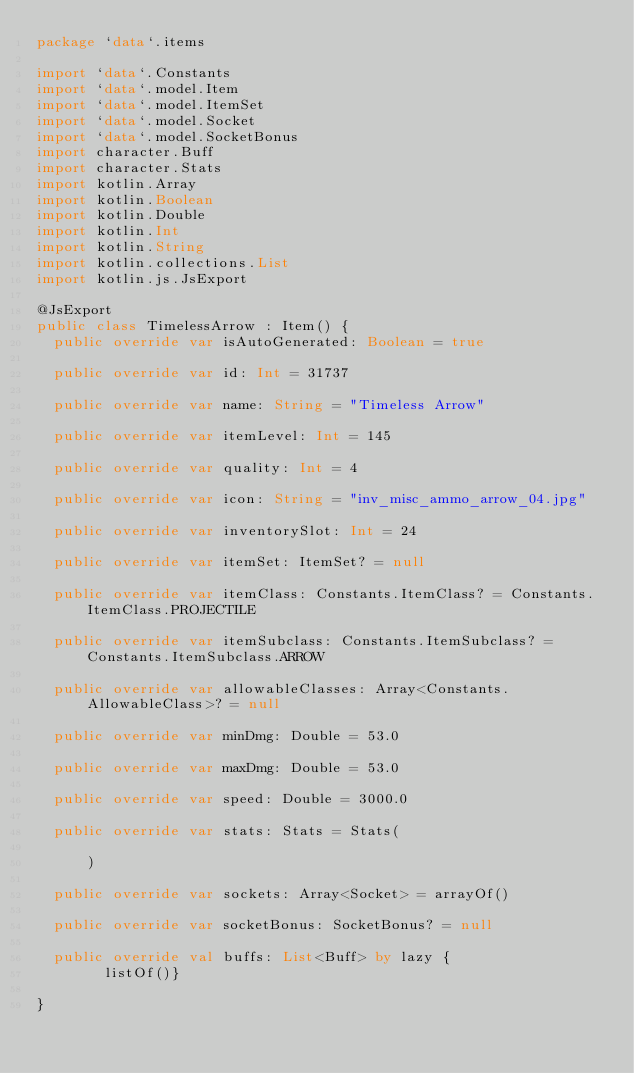Convert code to text. <code><loc_0><loc_0><loc_500><loc_500><_Kotlin_>package `data`.items

import `data`.Constants
import `data`.model.Item
import `data`.model.ItemSet
import `data`.model.Socket
import `data`.model.SocketBonus
import character.Buff
import character.Stats
import kotlin.Array
import kotlin.Boolean
import kotlin.Double
import kotlin.Int
import kotlin.String
import kotlin.collections.List
import kotlin.js.JsExport

@JsExport
public class TimelessArrow : Item() {
  public override var isAutoGenerated: Boolean = true

  public override var id: Int = 31737

  public override var name: String = "Timeless Arrow"

  public override var itemLevel: Int = 145

  public override var quality: Int = 4

  public override var icon: String = "inv_misc_ammo_arrow_04.jpg"

  public override var inventorySlot: Int = 24

  public override var itemSet: ItemSet? = null

  public override var itemClass: Constants.ItemClass? = Constants.ItemClass.PROJECTILE

  public override var itemSubclass: Constants.ItemSubclass? = Constants.ItemSubclass.ARROW

  public override var allowableClasses: Array<Constants.AllowableClass>? = null

  public override var minDmg: Double = 53.0

  public override var maxDmg: Double = 53.0

  public override var speed: Double = 3000.0

  public override var stats: Stats = Stats(

      )

  public override var sockets: Array<Socket> = arrayOf()

  public override var socketBonus: SocketBonus? = null

  public override val buffs: List<Buff> by lazy {
        listOf()}

}
</code> 